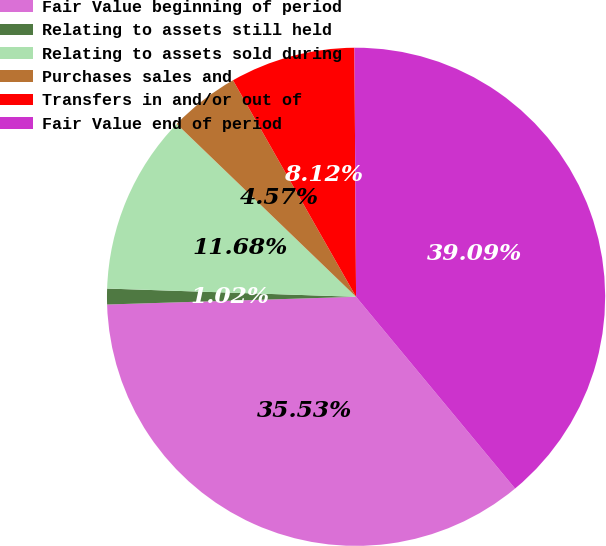Convert chart to OTSL. <chart><loc_0><loc_0><loc_500><loc_500><pie_chart><fcel>Fair Value beginning of period<fcel>Relating to assets still held<fcel>Relating to assets sold during<fcel>Purchases sales and<fcel>Transfers in and/or out of<fcel>Fair Value end of period<nl><fcel>35.53%<fcel>1.02%<fcel>11.68%<fcel>4.57%<fcel>8.12%<fcel>39.09%<nl></chart> 